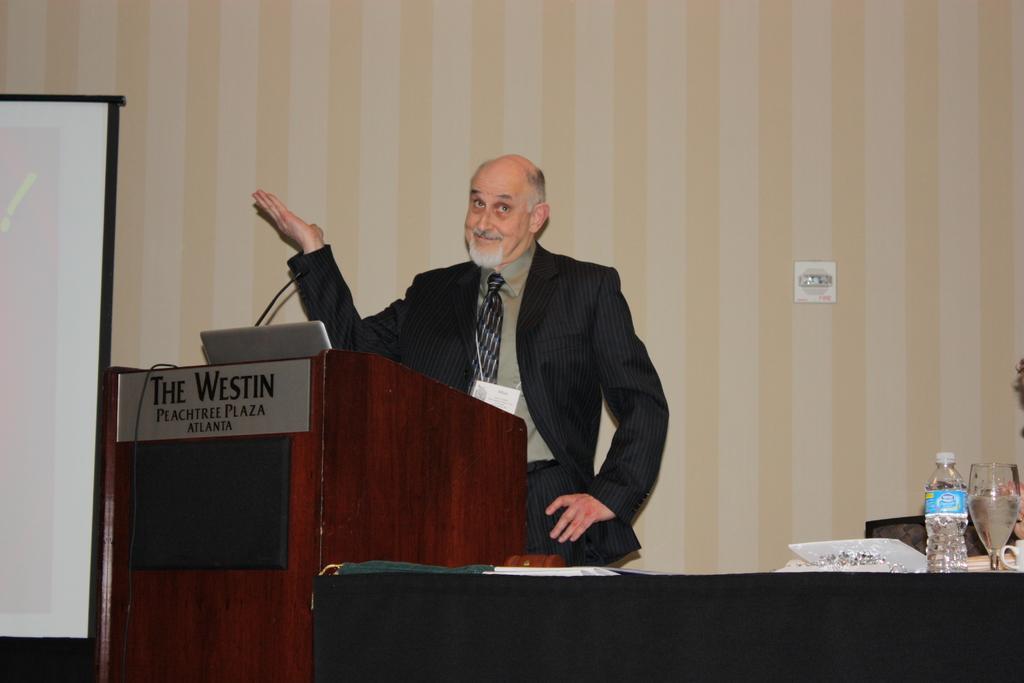Describe this image in one or two sentences. in this picture we can see a man standing in front of a podium and on the podium we can see a board, laptop and a mike. Here we can see a white board. This is a bottle and a glass. This man is holding a smile on his face. 